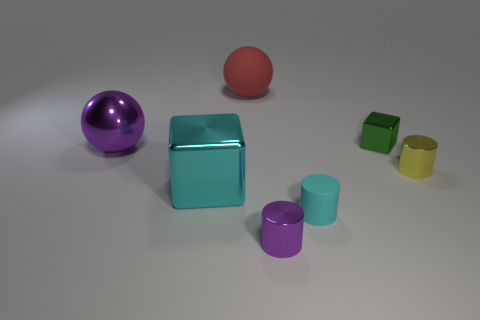What material is the object that is the same color as the rubber cylinder?
Ensure brevity in your answer.  Metal. Do the metallic cube that is to the right of the red ball and the red object have the same size?
Your response must be concise. No. There is a small metallic thing that is the same shape as the large cyan thing; what is its color?
Give a very brief answer. Green. The shiny thing that is on the left side of the block in front of the big sphere in front of the big red matte sphere is what shape?
Ensure brevity in your answer.  Sphere. Is the small green thing the same shape as the cyan metal thing?
Make the answer very short. Yes. There is a rubber object that is on the right side of the purple thing that is in front of the yellow cylinder; what is its shape?
Give a very brief answer. Cylinder. Are any cyan matte balls visible?
Provide a succinct answer. No. There is a cyan object that is right of the purple thing that is in front of the small cyan rubber thing; what number of big cyan things are behind it?
Offer a very short reply. 1. Is the shape of the large red rubber object the same as the tiny rubber thing that is in front of the matte ball?
Keep it short and to the point. No. Is the number of large matte objects greater than the number of metal blocks?
Give a very brief answer. No. 